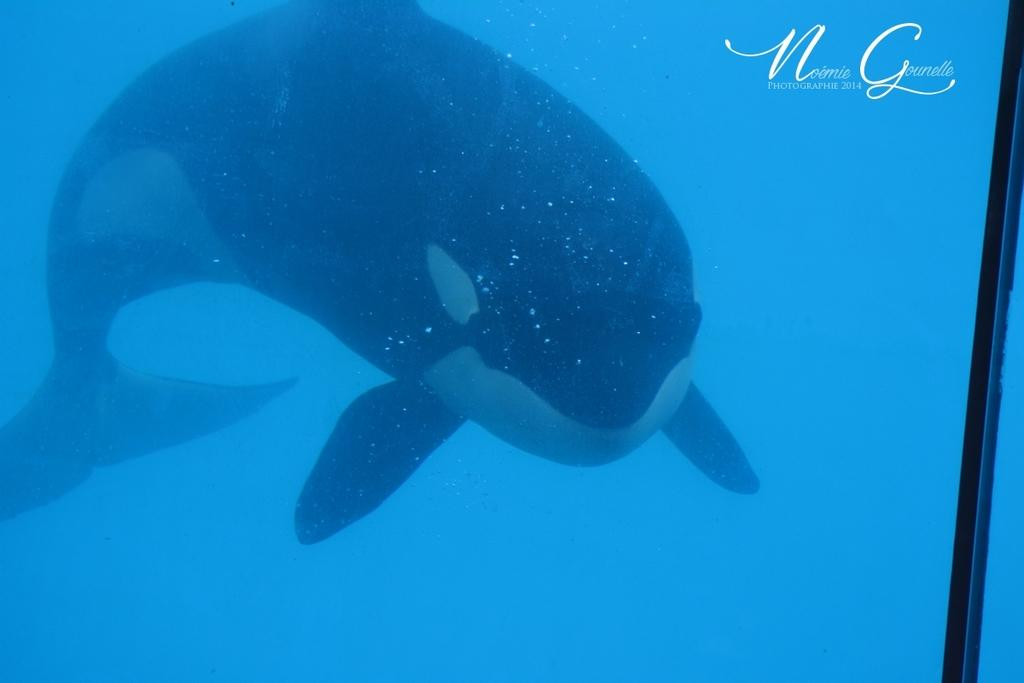What animal can be seen in the water in the image? There is a killer whale in the water in the image. What else is present on the glass in the image? There is text and a black line on the glass. How many waves can be seen in the image? There are no waves visible in the image; it features a killer whale in the water and text and a black line on the glass. What type of nail is being used by the killer whale in the image? There is no nail present in the image; it features a killer whale in the water and text and a black line on the glass. 